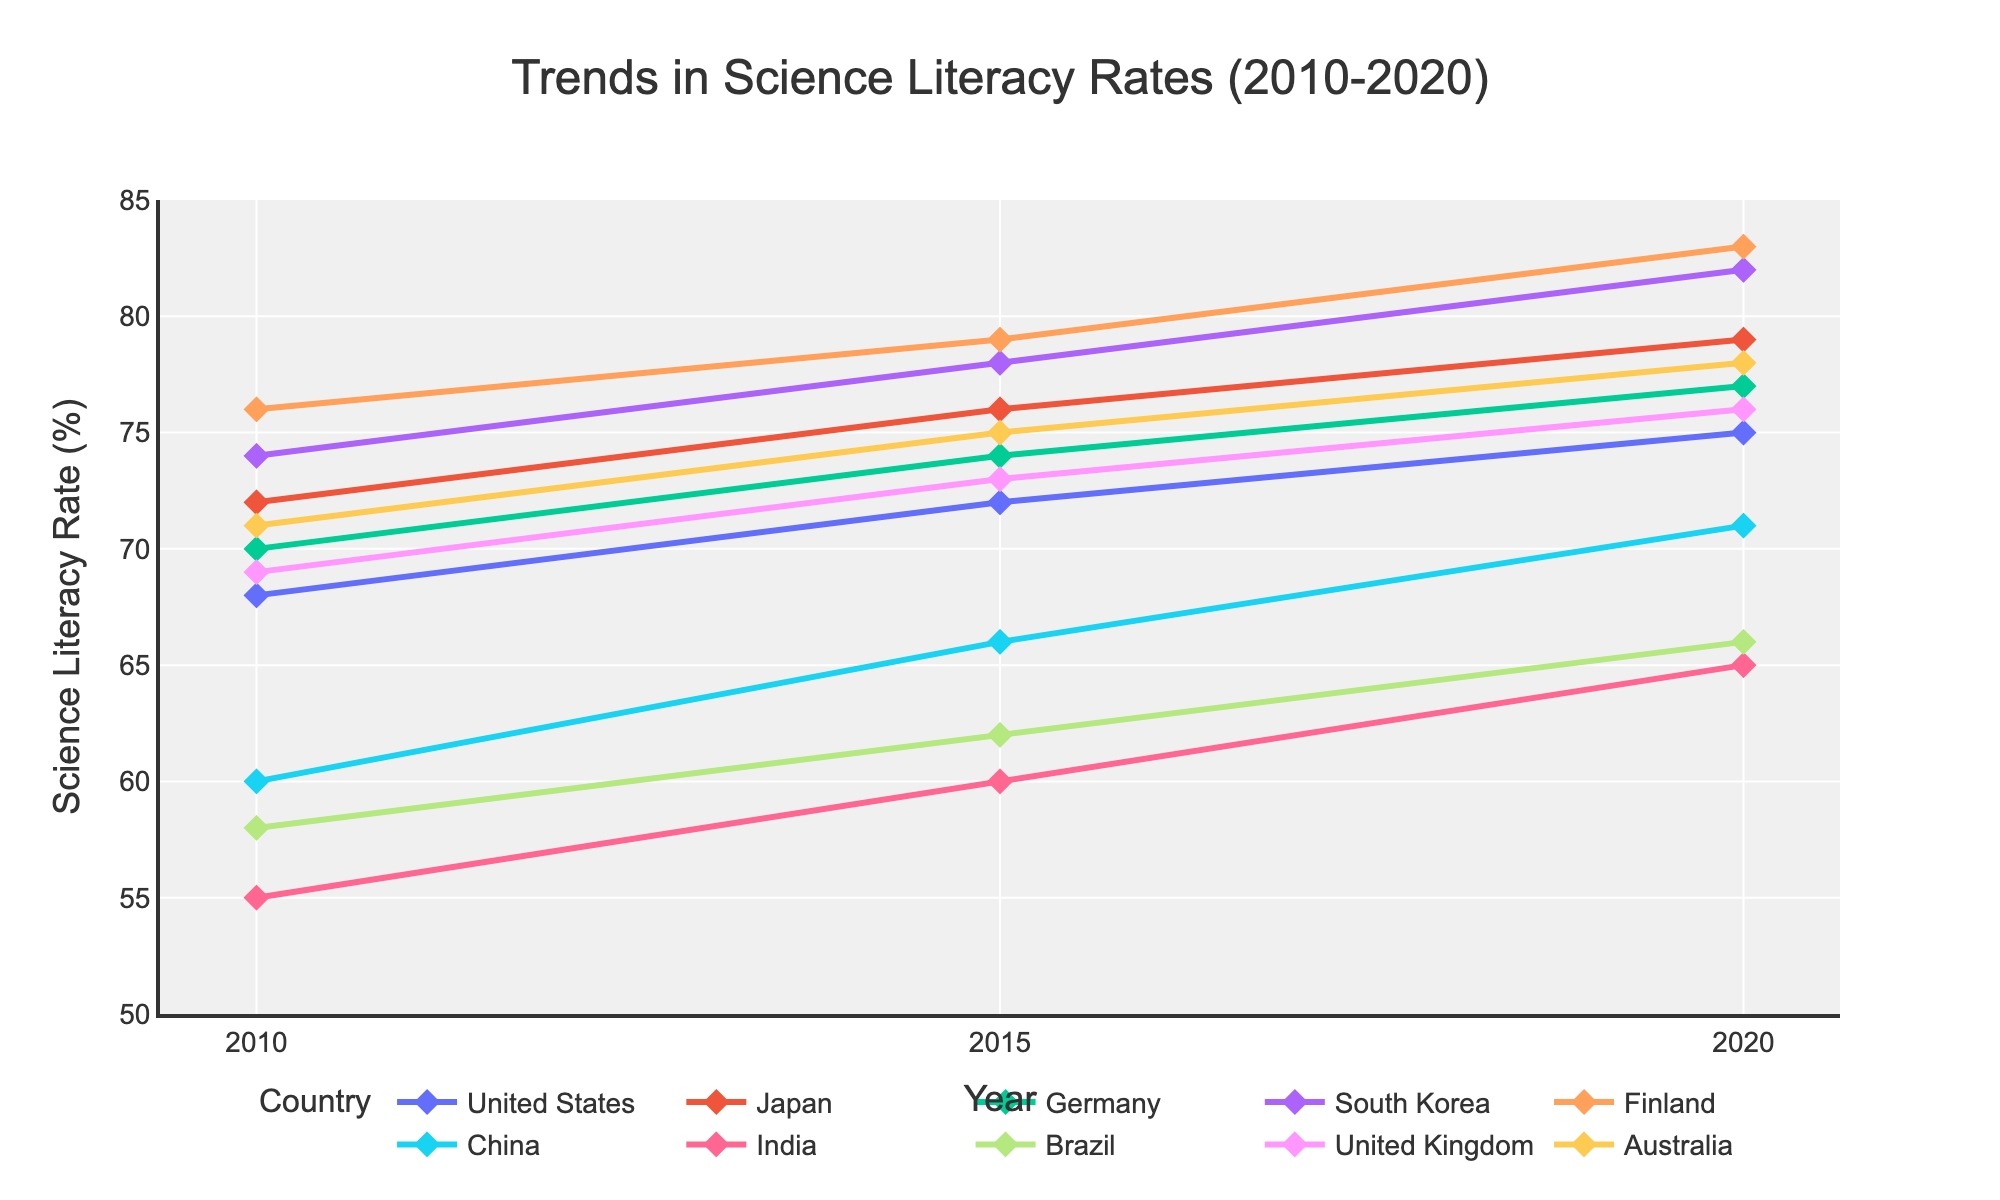What is the difference in the Science Literacy Rate between Japan and China in 2020? To find the difference, first identify the Science Literacy Rates for Japan and China in 2020, which are 79% and 71% respectively. Then, subtract the rate of China from Japan: 79 - 71
Answer: 8% Which country had the highest increase in Science Literacy Rate from 2010 to 2020? Observe the Science Literacy Rate for each country in 2010 and 2020, and calculate the increase for each: United States (75-68 = 7), Japan (79-72 = 7), Germany (77-70 = 7), South Korea (82-74 = 8), Finland (83-76 = 7), China (71-60 = 11), India (65-55 = 10), Brazil (66-58 = 8), United Kingdom (76-69 = 7), Australia (78-71 = 7). The country with the highest increase is China with an 11% increase.
Answer: China What is the average Science Literacy Rate across all countries in 2020? Sum the Science Literacy Rates of all countries in 2020 and divide by the number of countries: (75 + 79 + 77 + 82 + 83 + 71 + 65 + 66 + 76 + 78) / 10 = 752 / 10 = 75.2
Answer: 75.2% Which country had the smallest change in Science Literacy Rate between 2015 and 2020? To determine the smallest change, calculate the difference in Science Literacy Rate between 2015 and 2020 for each country: United States (75-72 = 3), Japan (79-76 = 3), Germany (77-74 = 3), South Korea (82-78 = 4), Finland (83-79 = 4), China (71-66 = 5), India (65-60 = 5), Brazil (66-62 = 4), United Kingdom (76-73 = 3), Australia (78-75 = 3). Several countries had a change of 3%, the smallest one, including the United States, Japan, Germany, United Kingdom, and Australia.
Answer: United States, Japan, Germany, United Kingdom, Australia How does the investment in STEM education in South Korea in 2015 compare to that in India in 2020? Find the percentage of GDP invested in STEM education for South Korea in 2015 and India in 2020, which are 1.2% and 0.8% respectively. The investment in STEM education in South Korea is greater than in India by 0.4%: 1.2 - 0.8
Answer: 0.4% Which country had consistently increasing Science Literacy Rates over the three periods (2010, 2015, 2020)? Identify countries with rates that increase each year. The trends for each country are: United States (68 -> 72 -> 75), Japan (72 -> 76 -> 79), Germany (70 -> 74 -> 77), South Korea (74 -> 78 -> 82), Finland (76 -> 79 -> 83), China (60 -> 66 -> 71), India (55 -> 60 -> 65), Brazil (58 -> 62 -> 66), United Kingdom (69 -> 73 -> 76), Australia (71 -> 75 -> 78). Every country shows a consistent increase over the years.
Answer: All countries What is the correlation between investment in STEM education and Science Literacy Rate for the United States from 2010 to 2020? Observe the trend: in 2010 (0.7% GDP investment, 68%), 2015 (0.8% GDP investment, 72%), and 2020 (0.9% GDP investment, 75%). As investment in STEM education increased, so did the Science Literacy Rate. This shows a positive correlation.
Answer: Positive correlation 